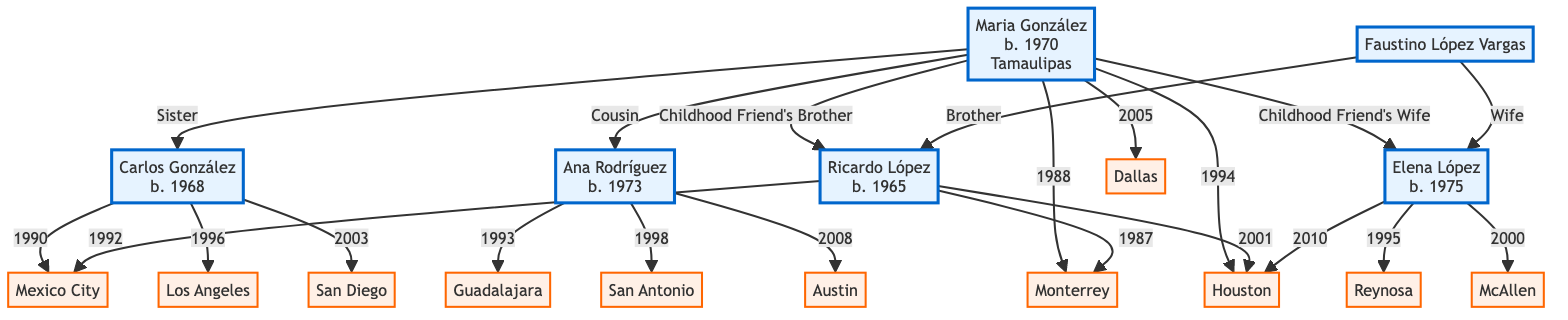What is Maria González's birth year? The diagram shows Maria González with the label "b. 1970" indicating her birth year.
Answer: 1970 Who is the brother of Carlos González? The diagram indicates that A (Maria González) has the relationship "Sister" with B (Carlos González), meaning Carlos has one sibling.
Answer: Maria González How many migration destinations does Ricardo López have? By reviewing the migration patterns for Ricardo López, he has three migration destinations listed: Monterrey, Mexico City, and Houston.
Answer: 3 What is the first migration destination of Ana Rodríguez? Ana Rodríguez's migration pattern shows the first destination listed as Guadalajara in the year 1993.
Answer: Guadalajara Which year did Elena López migrate to McAllen? The migration pattern for Elena López lists McAllen as her destination in the year 2000.
Answer: 2000 What relationship does Elena López have with Faustino López Vargas? The diagram indicates that Elena López is labeled as "Sister-in-law" and is connected to Faustino López Vargas.
Answer: Sister-in-law Where did Carlos González migrate in 1996? According to the migration pattern for Carlos González, he migrated to Los Angeles in the year 1996.
Answer: Los Angeles How many family members does Maria González have in the diagram? The diagram shows Maria González connected to four other family members: Carlos, Ana, Ricardo, and Elena.
Answer: 4 What was Maria González's reason for migrating to Houston? The migration pattern for Maria González states that her reason for migrating to Houston was for a "Job opportunity" in 1994.
Answer: Job opportunity 